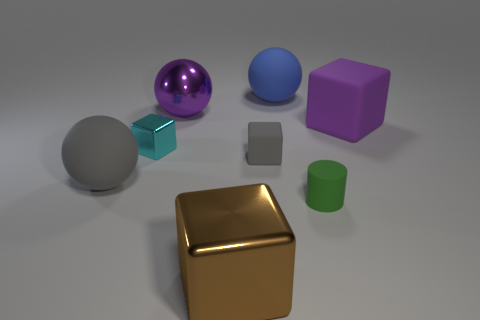Subtract all big gray spheres. How many spheres are left? 2 Add 1 small blue rubber blocks. How many objects exist? 9 Subtract all cyan cubes. How many cubes are left? 3 Subtract all cylinders. How many objects are left? 7 Subtract all red blocks. Subtract all cyan cylinders. How many blocks are left? 4 Subtract all small red rubber cylinders. Subtract all cyan things. How many objects are left? 7 Add 6 small cylinders. How many small cylinders are left? 7 Add 7 metal balls. How many metal balls exist? 8 Subtract 0 yellow cubes. How many objects are left? 8 